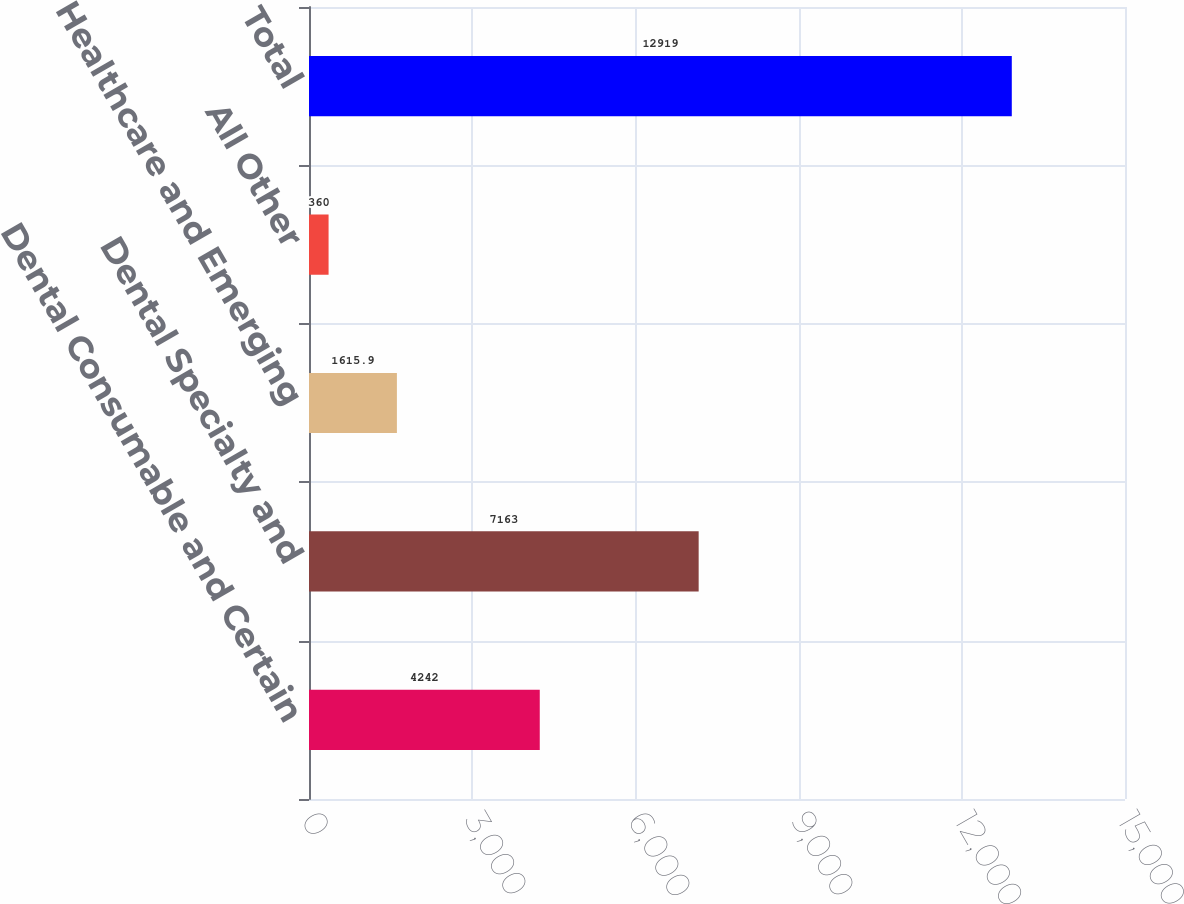Convert chart. <chart><loc_0><loc_0><loc_500><loc_500><bar_chart><fcel>Dental Consumable and Certain<fcel>Dental Specialty and<fcel>Healthcare and Emerging<fcel>All Other<fcel>Total<nl><fcel>4242<fcel>7163<fcel>1615.9<fcel>360<fcel>12919<nl></chart> 